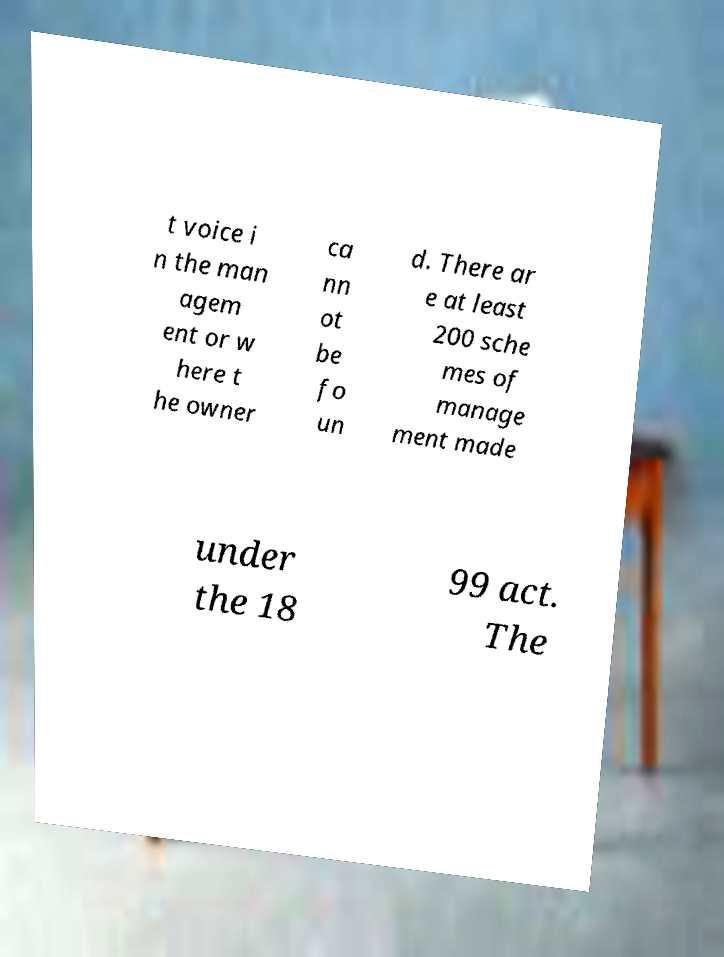I need the written content from this picture converted into text. Can you do that? t voice i n the man agem ent or w here t he owner ca nn ot be fo un d. There ar e at least 200 sche mes of manage ment made under the 18 99 act. The 